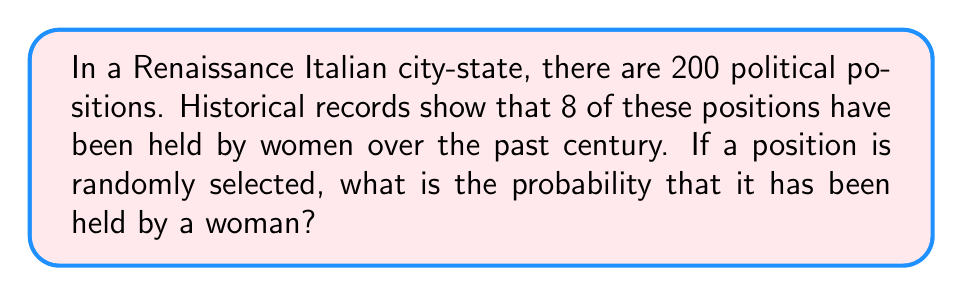Provide a solution to this math problem. To solve this problem, we need to use the concept of probability. The probability of an event is calculated by dividing the number of favorable outcomes by the total number of possible outcomes.

Let's define our variables:
$n$ = total number of political positions
$w$ = number of positions held by women

Given:
$n = 200$
$w = 8$

The probability $P$ of selecting a position that has been held by a woman is:

$$P = \frac{w}{n} = \frac{8}{200}$$

To simplify this fraction:

$$\frac{8}{200} = \frac{8 \div 8}{200 \div 8} = \frac{1}{25} = 0.04$$

Therefore, the probability of randomly selecting a position that has been held by a woman is $\frac{1}{25}$ or 0.04 or 4%.
Answer: $\frac{1}{25}$ or 0.04 